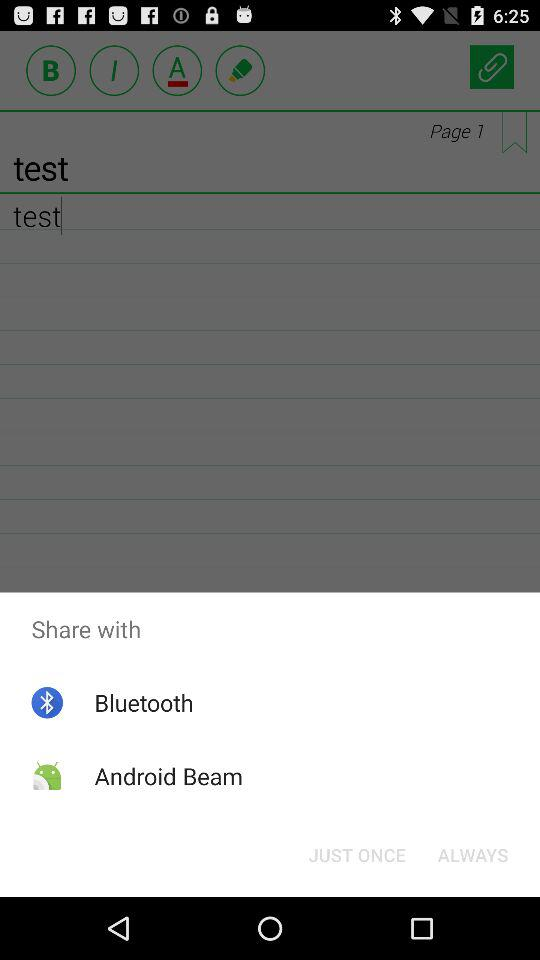Which options are given for sharing? The options given for sharing are "Bluetooth" and "Android Beam". 